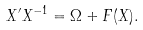Convert formula to latex. <formula><loc_0><loc_0><loc_500><loc_500>X ^ { \prime } X ^ { - 1 } = \Omega + F ( X ) .</formula> 